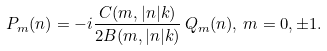Convert formula to latex. <formula><loc_0><loc_0><loc_500><loc_500>P _ { m } ( n ) = - i \frac { C ( m , | n | k ) } { 2 B ( m , | n | k ) } \, Q _ { m } ( n ) , \, m = 0 , \pm 1 .</formula> 